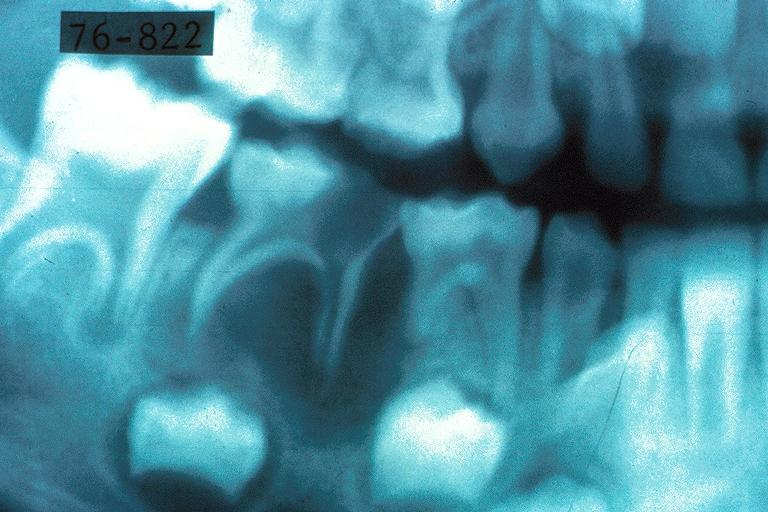what is present?
Answer the question using a single word or phrase. Oral 